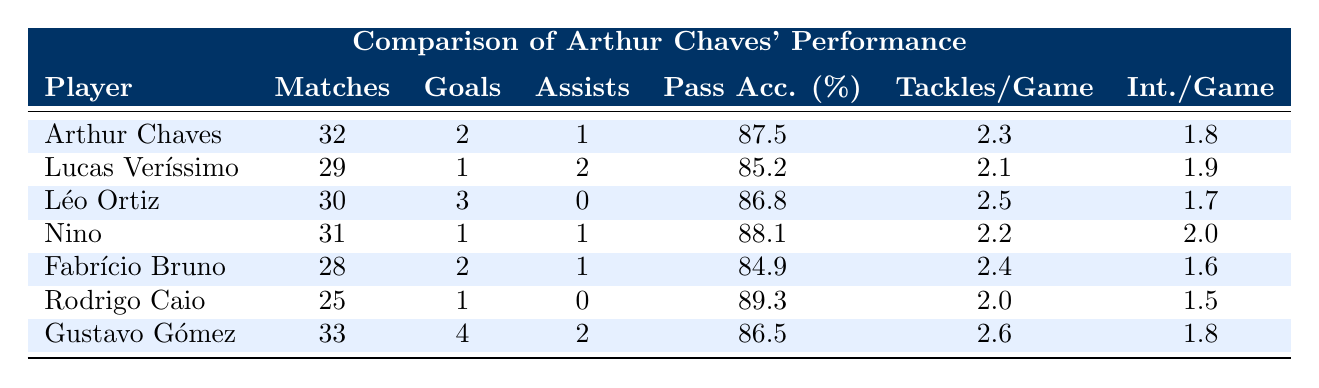What is Arthur Chaves' goals scored in the season? From the table, Arthur Chaves is recorded to have scored 2 goals in the season.
Answer: 2 How many assists did Léo Ortiz provide? The table indicates that Léo Ortiz provided 0 assists during the matches he played.
Answer: 0 Which player has the highest pass accuracy percentage? By examining the table, it is clear that Rodrigo Caio has the highest pass accuracy percentage at 89.3%.
Answer: 89.3 How many total goals did players in the table score combined? To find the total goals, we add up the goals scored by each player: 2 (Chaves) + 1 (Veríssimo) + 3 (Ortiz) + 1 (Nino) + 2 (Bruno) + 1 (Caio) + 4 (Gómez) = 14.
Answer: 14 Is Arthur Chaves' tackles per game higher than that of Nino? Arthur Chaves averages 2.3 tackles per game while Nino has 2.2 tackles per game, meaning Arthur Chaves does have a higher average.
Answer: Yes Which player has the least number of matches played? By reviewing the table, Rodrigo Caio has played the least number of matches, totaling 25.
Answer: 25 What is the average number of assists per game for the players listed? To find the average assists per game, we sum the assists: 1 (Chaves) + 2 (Veríssimo) + 0 (Ortiz) + 1 (Nino) + 1 (Bruno) + 0 (Caio) + 2 (Gómez) = 7. There are 7 players, so 7/7 = 1.
Answer: 1 Which player had the highest number of tackles per game? Looking through the table, Gustavo Gómez had the highest number of tackles per game with an average of 2.6.
Answer: 2.6 Did any player have more assists than goals? Checking the assists in relation to goals, Lucas Veríssimo with 2 assists and 1 goal qualifies, showing that he has more assists than goals.
Answer: Yes 